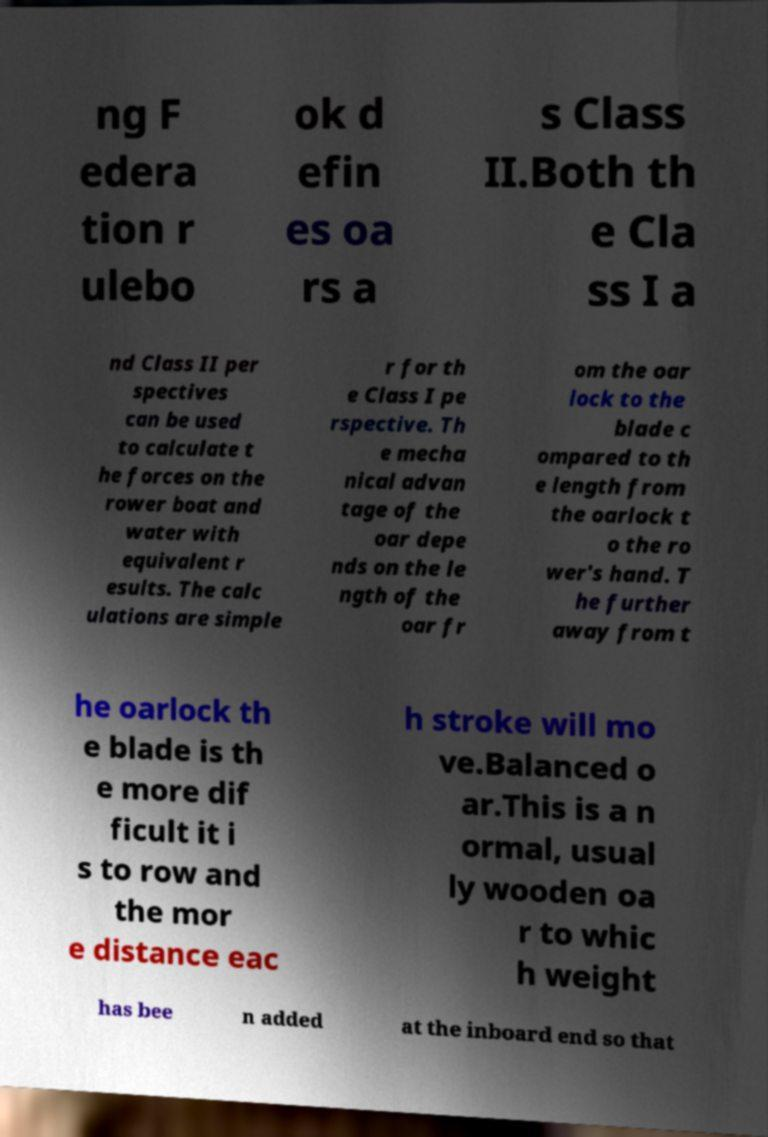Can you accurately transcribe the text from the provided image for me? ng F edera tion r ulebo ok d efin es oa rs a s Class II.Both th e Cla ss I a nd Class II per spectives can be used to calculate t he forces on the rower boat and water with equivalent r esults. The calc ulations are simple r for th e Class I pe rspective. Th e mecha nical advan tage of the oar depe nds on the le ngth of the oar fr om the oar lock to the blade c ompared to th e length from the oarlock t o the ro wer's hand. T he further away from t he oarlock th e blade is th e more dif ficult it i s to row and the mor e distance eac h stroke will mo ve.Balanced o ar.This is a n ormal, usual ly wooden oa r to whic h weight has bee n added at the inboard end so that 